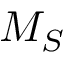Convert formula to latex. <formula><loc_0><loc_0><loc_500><loc_500>M _ { S }</formula> 